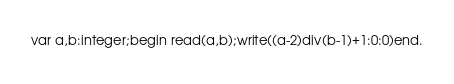Convert code to text. <code><loc_0><loc_0><loc_500><loc_500><_Pascal_>var a,b:integer;begin read(a,b);write((a-2)div(b-1)+1:0:0)end.</code> 